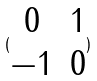<formula> <loc_0><loc_0><loc_500><loc_500>( \begin{matrix} 0 & 1 \\ - 1 & 0 \\ \end{matrix} )</formula> 